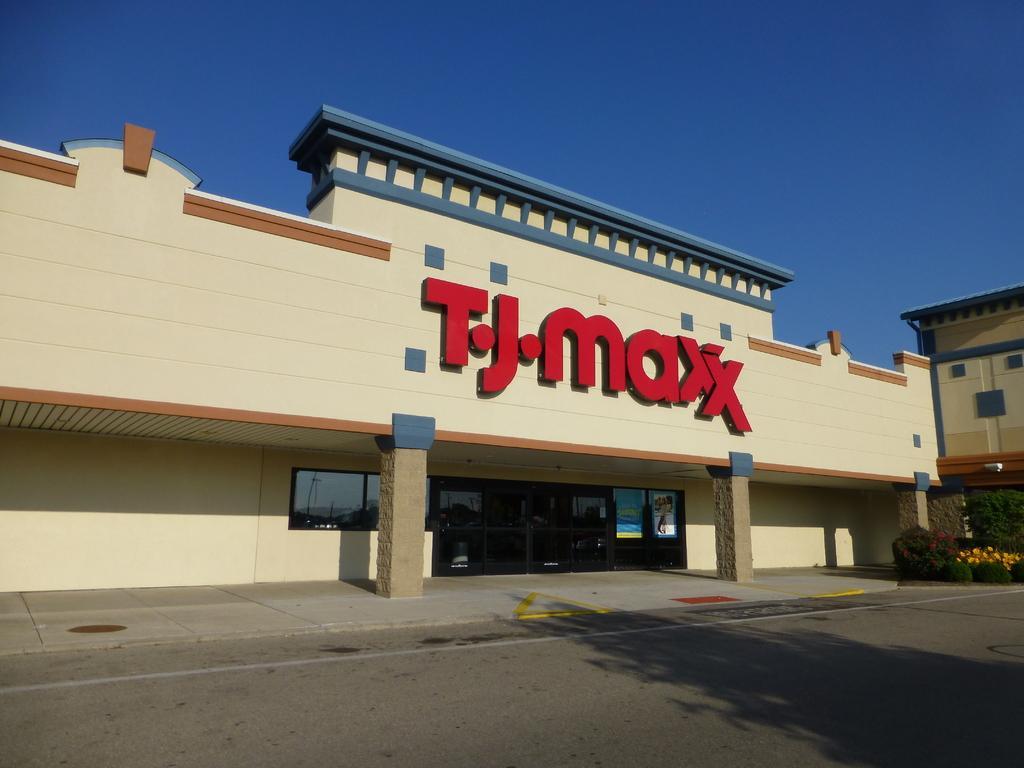In one or two sentences, can you explain what this image depicts? In this image I can see a building which is cream, brown and blue in color and the road. In the background I can see another building, few trees, few flowers which are yellow and red in color and the sky. 